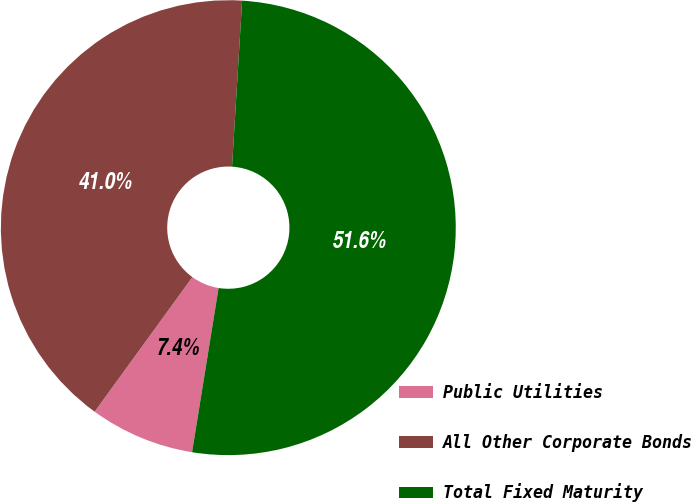Convert chart. <chart><loc_0><loc_0><loc_500><loc_500><pie_chart><fcel>Public Utilities<fcel>All Other Corporate Bonds<fcel>Total Fixed Maturity<nl><fcel>7.45%<fcel>40.97%<fcel>51.58%<nl></chart> 